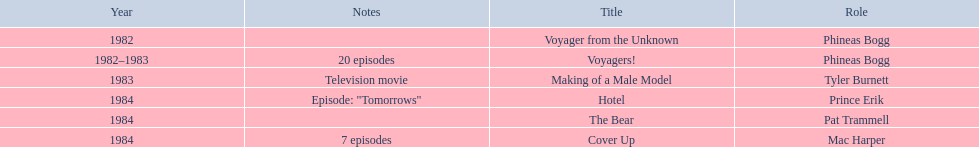In how many titles on this list did he not play the role of phineas bogg? 4. 